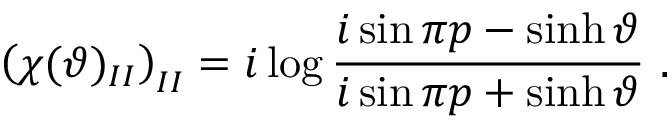<formula> <loc_0><loc_0><loc_500><loc_500>\left ( \chi ( \vartheta ) _ { I I } \right ) _ { I I } = i \log \frac { i \sin \pi p - \sinh \vartheta } { i \sin \pi p + \sinh \vartheta } \, .</formula> 